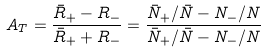Convert formula to latex. <formula><loc_0><loc_0><loc_500><loc_500>A _ { T } = \frac { \bar { R } _ { + } - R _ { - } } { \bar { R } _ { + } + R _ { - } } = \frac { \bar { N } _ { + } / \bar { N } - N _ { - } / N } { \bar { N } _ { + } / \bar { N } - N _ { - } / N }</formula> 